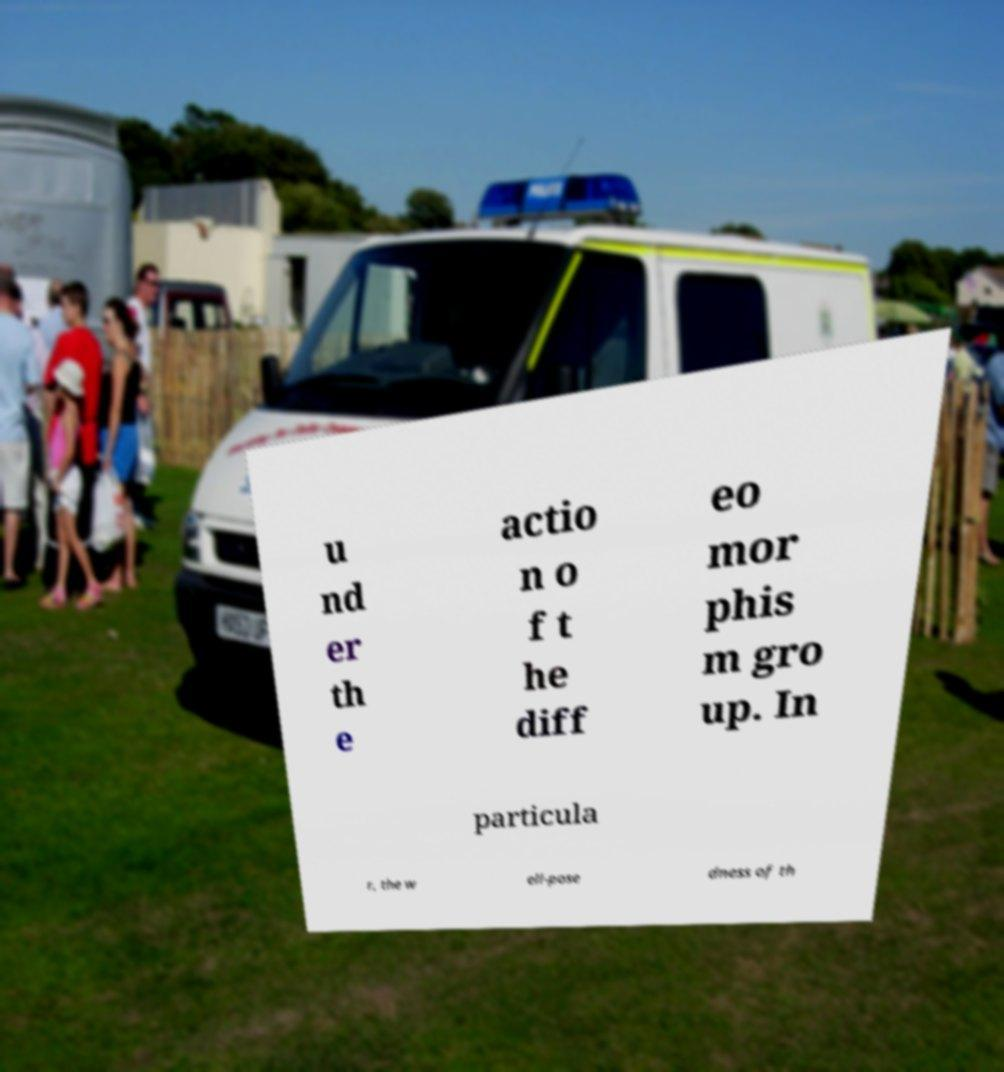For documentation purposes, I need the text within this image transcribed. Could you provide that? u nd er th e actio n o f t he diff eo mor phis m gro up. In particula r, the w ell-pose dness of th 